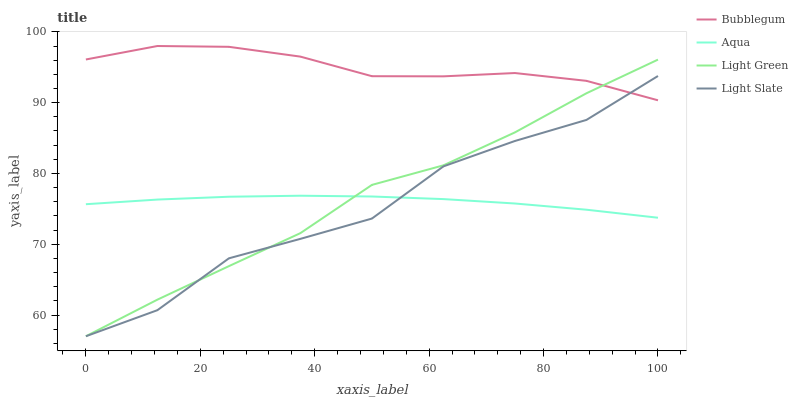Does Light Slate have the minimum area under the curve?
Answer yes or no. Yes. Does Bubblegum have the maximum area under the curve?
Answer yes or no. Yes. Does Aqua have the minimum area under the curve?
Answer yes or no. No. Does Aqua have the maximum area under the curve?
Answer yes or no. No. Is Aqua the smoothest?
Answer yes or no. Yes. Is Light Slate the roughest?
Answer yes or no. Yes. Is Light Green the smoothest?
Answer yes or no. No. Is Light Green the roughest?
Answer yes or no. No. Does Aqua have the lowest value?
Answer yes or no. No. Does Light Green have the highest value?
Answer yes or no. No. Is Aqua less than Bubblegum?
Answer yes or no. Yes. Is Bubblegum greater than Aqua?
Answer yes or no. Yes. Does Aqua intersect Bubblegum?
Answer yes or no. No. 